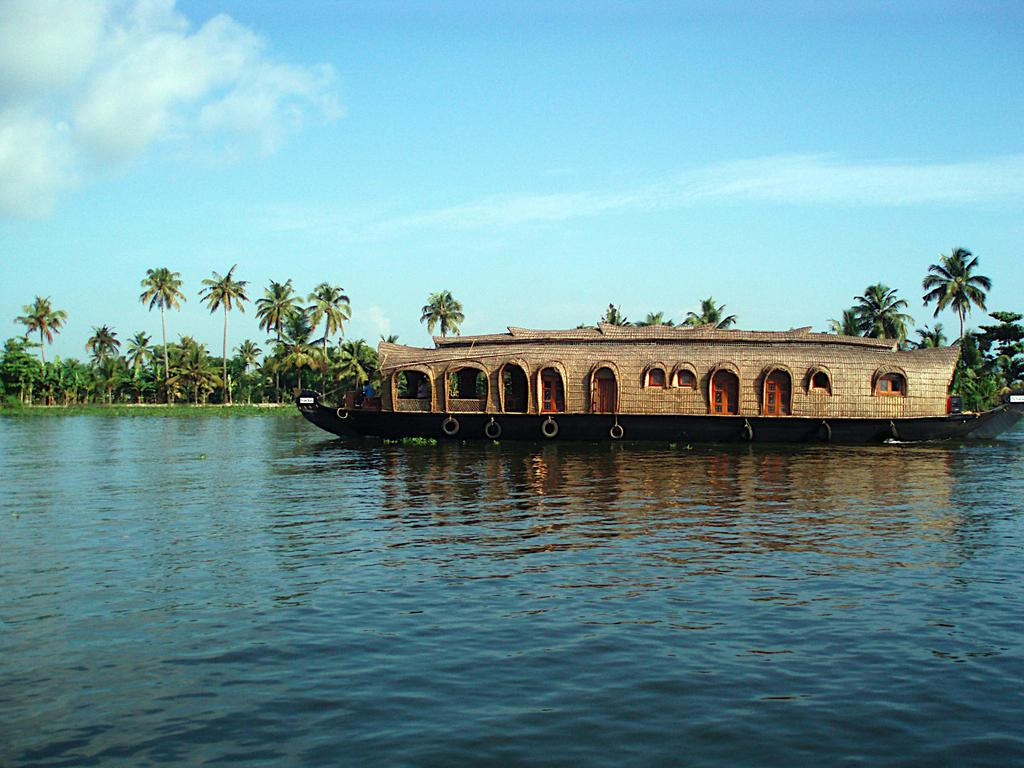What is the main subject in the image? There is a boat in the image. What is the boat situated in? The boat is in water, as seen in the image. What can be seen in the background of the image? There are trees and a clear sky in the background of the image. What type of flesh can be seen hanging from the trees in the image? There is no flesh visible in the image; only trees and a clear sky are present in the background. 